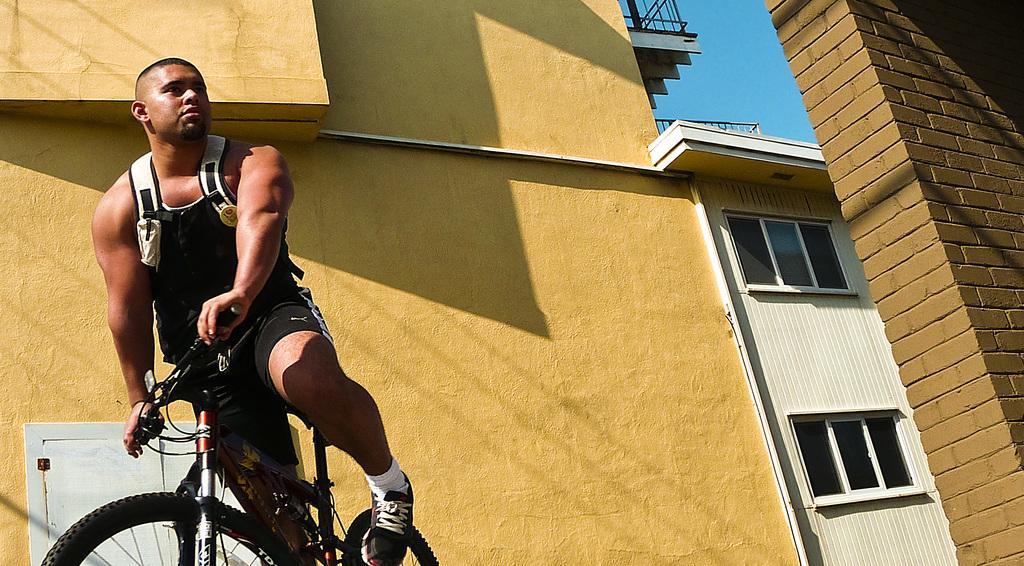Who or what is the main subject in the image? There is a person in the image. What is the person doing in the image? The person is sitting on a bicycle. What can be seen behind the person in the image? There is a yellow wall and a building visible in the background of the image. Reasoning: Let's think step by step by step in order to produce the conversation. We start by identifying the main subject in the image, which is the person. Then, we describe what the person is doing, which is sitting on a bicycle. Finally, we mention the background elements, including the yellow wall and the building. Each question is designed to elicit a specific detail about the image that is known from the provided facts. Absurd Question/Answer: What flavor of ice cream is the person holding in the image? There is no ice cream present in the image; the person is sitting on a bicycle. What type of body part is the person using to pedal the bicycle? The question is not present in the image, as it only shows the person sitting on the bicycle, not pedaling it. Where is the bucket that the person is using to water the plants in the image? There is no bucket or plants present in the image; the person is sitting on a bicycle. 